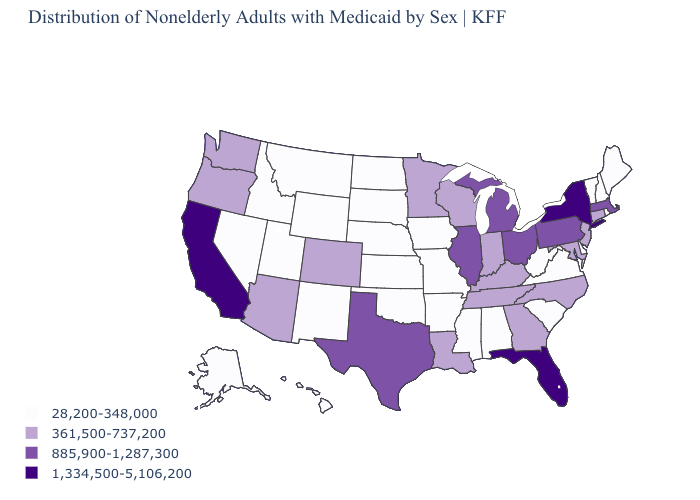What is the value of Michigan?
Keep it brief. 885,900-1,287,300. Name the states that have a value in the range 361,500-737,200?
Answer briefly. Arizona, Colorado, Connecticut, Georgia, Indiana, Kentucky, Louisiana, Maryland, Minnesota, New Jersey, North Carolina, Oregon, Tennessee, Washington, Wisconsin. Name the states that have a value in the range 28,200-348,000?
Keep it brief. Alabama, Alaska, Arkansas, Delaware, Hawaii, Idaho, Iowa, Kansas, Maine, Mississippi, Missouri, Montana, Nebraska, Nevada, New Hampshire, New Mexico, North Dakota, Oklahoma, Rhode Island, South Carolina, South Dakota, Utah, Vermont, Virginia, West Virginia, Wyoming. Does the map have missing data?
Quick response, please. No. What is the value of Wyoming?
Keep it brief. 28,200-348,000. Does California have the highest value in the West?
Concise answer only. Yes. Name the states that have a value in the range 361,500-737,200?
Concise answer only. Arizona, Colorado, Connecticut, Georgia, Indiana, Kentucky, Louisiana, Maryland, Minnesota, New Jersey, North Carolina, Oregon, Tennessee, Washington, Wisconsin. Among the states that border New Hampshire , which have the highest value?
Keep it brief. Massachusetts. What is the highest value in states that border West Virginia?
Write a very short answer. 885,900-1,287,300. What is the highest value in states that border Delaware?
Concise answer only. 885,900-1,287,300. What is the value of Utah?
Quick response, please. 28,200-348,000. Which states have the highest value in the USA?
Keep it brief. California, Florida, New York. What is the highest value in the USA?
Answer briefly. 1,334,500-5,106,200. What is the value of Wyoming?
Concise answer only. 28,200-348,000. How many symbols are there in the legend?
Write a very short answer. 4. 